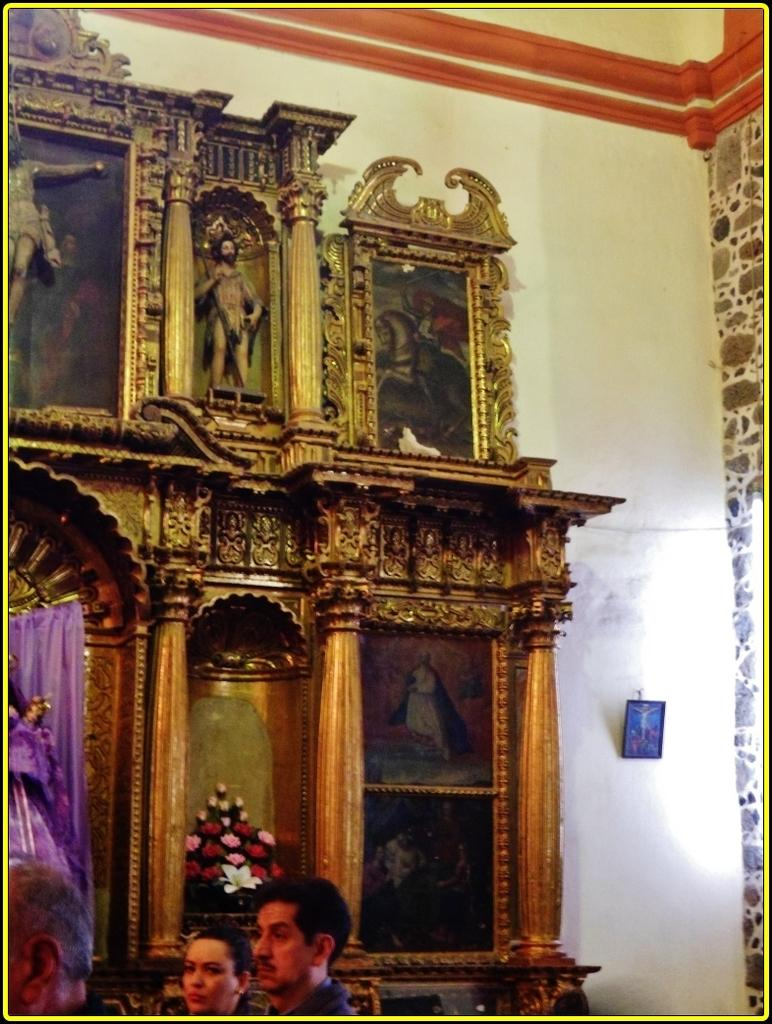What are the people in the image doing? There are persons sitting in the image. What can be seen on the wall in the image? There are wall hangings on the wall. What type of object is present in the image that resembles a person? There is a statue in the image. What type of window treatment is visible in the image? There is a curtain in the image. What type of decorative items can be seen in the image? There are bouquets in the image. What type of ear is visible on the statue in the image? There is no ear visible on the statue in the image, as the statue does not have a human-like appearance. 